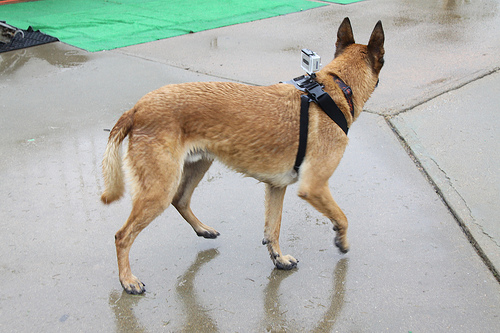<image>
Is there a camera on the dog? Yes. Looking at the image, I can see the camera is positioned on top of the dog, with the dog providing support. Is there a sidewalk in front of the dog? No. The sidewalk is not in front of the dog. The spatial positioning shows a different relationship between these objects. 